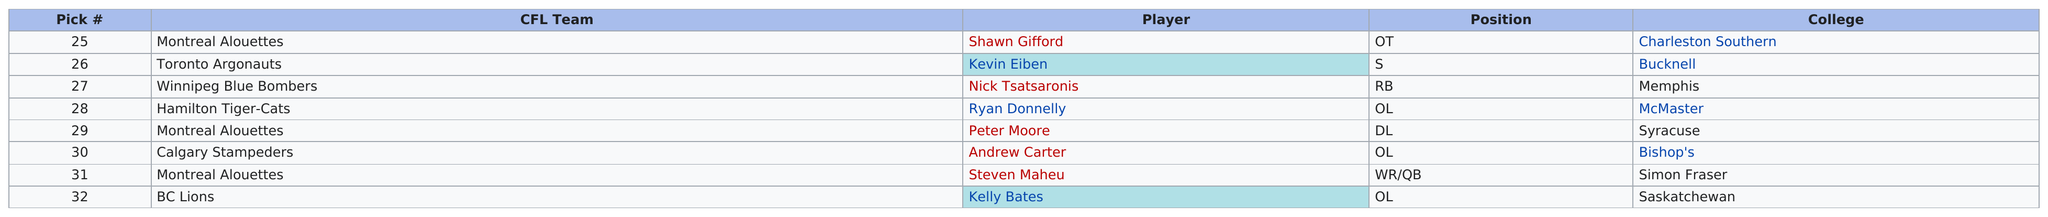Give some essential details in this illustration. The Hamilton Tiger-Cats were the team that drafted the only offensive lineman from McMaster College. The first selection in round four was Shawn Gifford. The Montreal Alouettes have the most picks in round four. The Montreal Alouettes filled a position prior to drafting Peter Moore. The first player picked in round four was Shawn Gifford. 